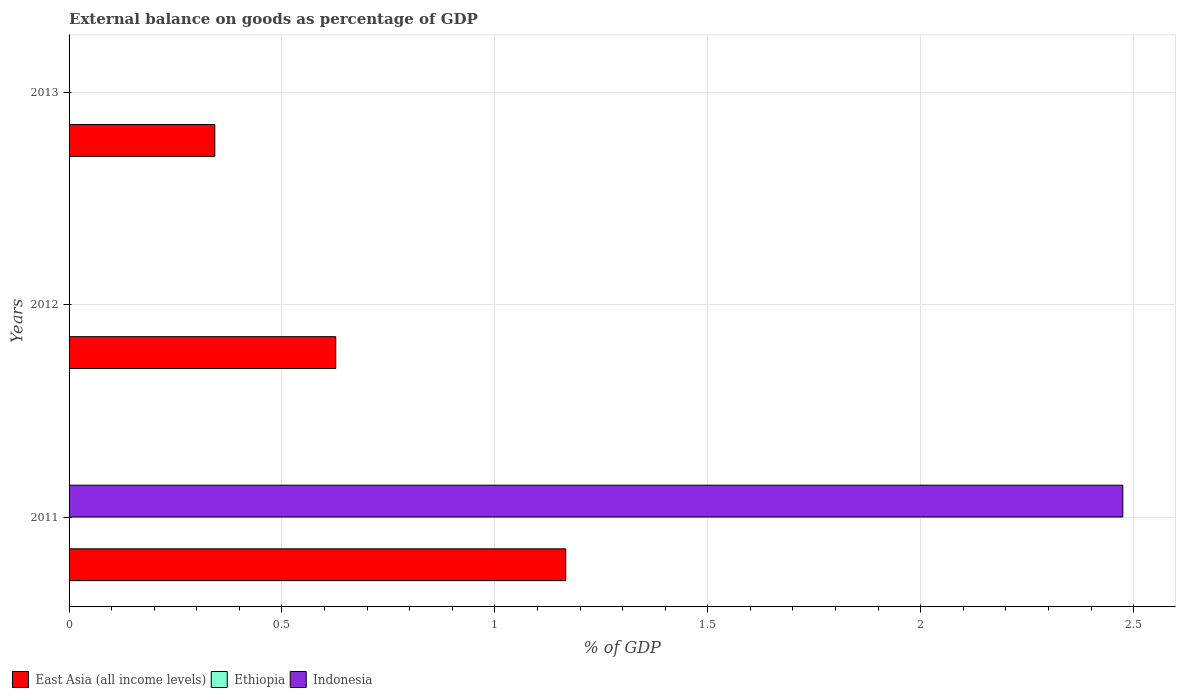Are the number of bars per tick equal to the number of legend labels?
Make the answer very short. No. How many bars are there on the 2nd tick from the top?
Your response must be concise. 1. How many bars are there on the 3rd tick from the bottom?
Keep it short and to the point. 1. What is the external balance on goods as percentage of GDP in Ethiopia in 2011?
Ensure brevity in your answer.  0. Across all years, what is the maximum external balance on goods as percentage of GDP in East Asia (all income levels)?
Your answer should be compact. 1.17. Across all years, what is the minimum external balance on goods as percentage of GDP in East Asia (all income levels)?
Your answer should be very brief. 0.34. What is the total external balance on goods as percentage of GDP in Ethiopia in the graph?
Give a very brief answer. 0. What is the difference between the external balance on goods as percentage of GDP in East Asia (all income levels) in 2011 and that in 2012?
Make the answer very short. 0.54. What is the difference between the external balance on goods as percentage of GDP in Ethiopia in 2011 and the external balance on goods as percentage of GDP in East Asia (all income levels) in 2012?
Your answer should be very brief. -0.63. What is the average external balance on goods as percentage of GDP in East Asia (all income levels) per year?
Your response must be concise. 0.71. In the year 2011, what is the difference between the external balance on goods as percentage of GDP in Indonesia and external balance on goods as percentage of GDP in East Asia (all income levels)?
Your answer should be very brief. 1.31. In how many years, is the external balance on goods as percentage of GDP in Ethiopia greater than 1.4 %?
Keep it short and to the point. 0. What is the ratio of the external balance on goods as percentage of GDP in East Asia (all income levels) in 2011 to that in 2012?
Your response must be concise. 1.86. What is the difference between the highest and the second highest external balance on goods as percentage of GDP in East Asia (all income levels)?
Provide a succinct answer. 0.54. What is the difference between the highest and the lowest external balance on goods as percentage of GDP in Indonesia?
Your answer should be compact. 2.47. In how many years, is the external balance on goods as percentage of GDP in East Asia (all income levels) greater than the average external balance on goods as percentage of GDP in East Asia (all income levels) taken over all years?
Offer a terse response. 1. How many years are there in the graph?
Ensure brevity in your answer.  3. How are the legend labels stacked?
Offer a very short reply. Horizontal. What is the title of the graph?
Ensure brevity in your answer.  External balance on goods as percentage of GDP. Does "Georgia" appear as one of the legend labels in the graph?
Ensure brevity in your answer.  No. What is the label or title of the X-axis?
Your response must be concise. % of GDP. What is the % of GDP in East Asia (all income levels) in 2011?
Provide a short and direct response. 1.17. What is the % of GDP of Indonesia in 2011?
Provide a succinct answer. 2.47. What is the % of GDP of East Asia (all income levels) in 2012?
Offer a very short reply. 0.63. What is the % of GDP of East Asia (all income levels) in 2013?
Offer a very short reply. 0.34. Across all years, what is the maximum % of GDP of East Asia (all income levels)?
Ensure brevity in your answer.  1.17. Across all years, what is the maximum % of GDP in Indonesia?
Offer a terse response. 2.47. Across all years, what is the minimum % of GDP of East Asia (all income levels)?
Give a very brief answer. 0.34. Across all years, what is the minimum % of GDP in Indonesia?
Provide a succinct answer. 0. What is the total % of GDP of East Asia (all income levels) in the graph?
Provide a succinct answer. 2.13. What is the total % of GDP of Ethiopia in the graph?
Your answer should be compact. 0. What is the total % of GDP in Indonesia in the graph?
Offer a very short reply. 2.47. What is the difference between the % of GDP in East Asia (all income levels) in 2011 and that in 2012?
Ensure brevity in your answer.  0.54. What is the difference between the % of GDP of East Asia (all income levels) in 2011 and that in 2013?
Keep it short and to the point. 0.82. What is the difference between the % of GDP of East Asia (all income levels) in 2012 and that in 2013?
Provide a short and direct response. 0.28. What is the average % of GDP of East Asia (all income levels) per year?
Provide a short and direct response. 0.71. What is the average % of GDP in Ethiopia per year?
Ensure brevity in your answer.  0. What is the average % of GDP of Indonesia per year?
Your response must be concise. 0.82. In the year 2011, what is the difference between the % of GDP of East Asia (all income levels) and % of GDP of Indonesia?
Provide a succinct answer. -1.31. What is the ratio of the % of GDP of East Asia (all income levels) in 2011 to that in 2012?
Ensure brevity in your answer.  1.86. What is the ratio of the % of GDP in East Asia (all income levels) in 2011 to that in 2013?
Keep it short and to the point. 3.41. What is the ratio of the % of GDP in East Asia (all income levels) in 2012 to that in 2013?
Make the answer very short. 1.83. What is the difference between the highest and the second highest % of GDP in East Asia (all income levels)?
Give a very brief answer. 0.54. What is the difference between the highest and the lowest % of GDP of East Asia (all income levels)?
Offer a terse response. 0.82. What is the difference between the highest and the lowest % of GDP in Indonesia?
Your response must be concise. 2.47. 